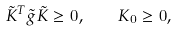<formula> <loc_0><loc_0><loc_500><loc_500>\tilde { K } ^ { T } \tilde { g } \tilde { K } \geq 0 , \quad K _ { 0 } \geq 0 ,</formula> 